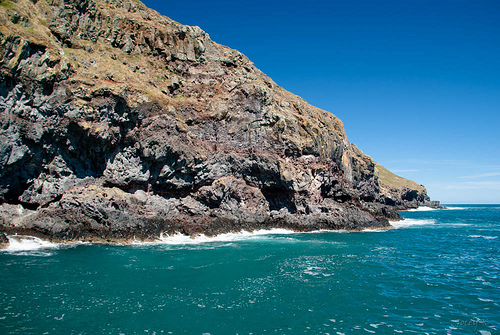<image>
Is the rock in front of the sky? Yes. The rock is positioned in front of the sky, appearing closer to the camera viewpoint. 